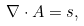<formula> <loc_0><loc_0><loc_500><loc_500>\nabla \cdot { A } = s ,</formula> 